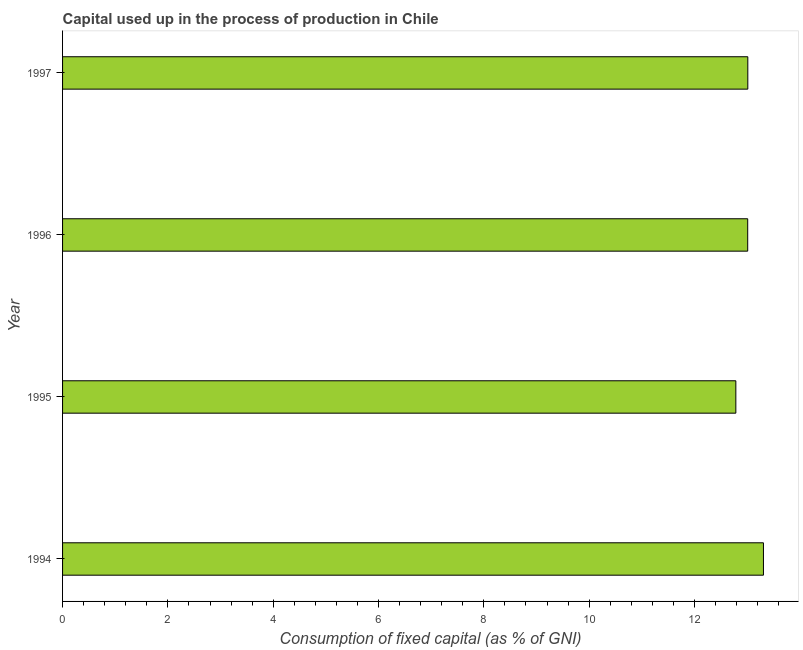Does the graph contain any zero values?
Give a very brief answer. No. Does the graph contain grids?
Make the answer very short. No. What is the title of the graph?
Your answer should be very brief. Capital used up in the process of production in Chile. What is the label or title of the X-axis?
Offer a very short reply. Consumption of fixed capital (as % of GNI). What is the consumption of fixed capital in 1995?
Your response must be concise. 12.79. Across all years, what is the maximum consumption of fixed capital?
Provide a short and direct response. 13.31. Across all years, what is the minimum consumption of fixed capital?
Ensure brevity in your answer.  12.79. What is the sum of the consumption of fixed capital?
Your answer should be compact. 52.12. What is the difference between the consumption of fixed capital in 1994 and 1997?
Your response must be concise. 0.3. What is the average consumption of fixed capital per year?
Provide a succinct answer. 13.03. What is the median consumption of fixed capital?
Offer a very short reply. 13.01. In how many years, is the consumption of fixed capital greater than 12.8 %?
Offer a very short reply. 3. What is the ratio of the consumption of fixed capital in 1996 to that in 1997?
Make the answer very short. 1. What is the difference between the highest and the second highest consumption of fixed capital?
Give a very brief answer. 0.3. Is the sum of the consumption of fixed capital in 1995 and 1996 greater than the maximum consumption of fixed capital across all years?
Keep it short and to the point. Yes. What is the difference between the highest and the lowest consumption of fixed capital?
Provide a short and direct response. 0.52. How many bars are there?
Keep it short and to the point. 4. Are all the bars in the graph horizontal?
Keep it short and to the point. Yes. How many years are there in the graph?
Your answer should be compact. 4. What is the Consumption of fixed capital (as % of GNI) in 1994?
Your response must be concise. 13.31. What is the Consumption of fixed capital (as % of GNI) of 1995?
Keep it short and to the point. 12.79. What is the Consumption of fixed capital (as % of GNI) of 1996?
Provide a short and direct response. 13.01. What is the Consumption of fixed capital (as % of GNI) of 1997?
Ensure brevity in your answer.  13.01. What is the difference between the Consumption of fixed capital (as % of GNI) in 1994 and 1995?
Your answer should be compact. 0.52. What is the difference between the Consumption of fixed capital (as % of GNI) in 1994 and 1996?
Provide a short and direct response. 0.3. What is the difference between the Consumption of fixed capital (as % of GNI) in 1994 and 1997?
Ensure brevity in your answer.  0.3. What is the difference between the Consumption of fixed capital (as % of GNI) in 1995 and 1996?
Ensure brevity in your answer.  -0.23. What is the difference between the Consumption of fixed capital (as % of GNI) in 1995 and 1997?
Make the answer very short. -0.23. What is the difference between the Consumption of fixed capital (as % of GNI) in 1996 and 1997?
Give a very brief answer. -0. What is the ratio of the Consumption of fixed capital (as % of GNI) in 1994 to that in 1995?
Your answer should be compact. 1.04. What is the ratio of the Consumption of fixed capital (as % of GNI) in 1995 to that in 1997?
Your answer should be compact. 0.98. 